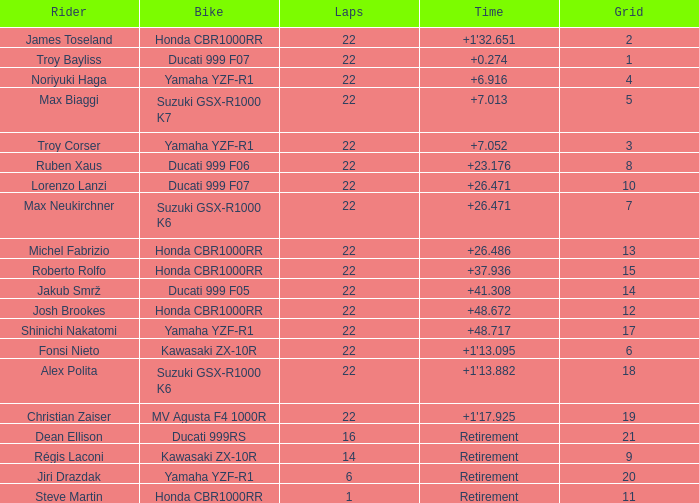Could you parse the entire table? {'header': ['Rider', 'Bike', 'Laps', 'Time', 'Grid'], 'rows': [['James Toseland', 'Honda CBR1000RR', '22', "+1'32.651", '2'], ['Troy Bayliss', 'Ducati 999 F07', '22', '+0.274', '1'], ['Noriyuki Haga', 'Yamaha YZF-R1', '22', '+6.916', '4'], ['Max Biaggi', 'Suzuki GSX-R1000 K7', '22', '+7.013', '5'], ['Troy Corser', 'Yamaha YZF-R1', '22', '+7.052', '3'], ['Ruben Xaus', 'Ducati 999 F06', '22', '+23.176', '8'], ['Lorenzo Lanzi', 'Ducati 999 F07', '22', '+26.471', '10'], ['Max Neukirchner', 'Suzuki GSX-R1000 K6', '22', '+26.471', '7'], ['Michel Fabrizio', 'Honda CBR1000RR', '22', '+26.486', '13'], ['Roberto Rolfo', 'Honda CBR1000RR', '22', '+37.936', '15'], ['Jakub Smrž', 'Ducati 999 F05', '22', '+41.308', '14'], ['Josh Brookes', 'Honda CBR1000RR', '22', '+48.672', '12'], ['Shinichi Nakatomi', 'Yamaha YZF-R1', '22', '+48.717', '17'], ['Fonsi Nieto', 'Kawasaki ZX-10R', '22', "+1'13.095", '6'], ['Alex Polita', 'Suzuki GSX-R1000 K6', '22', "+1'13.882", '18'], ['Christian Zaiser', 'MV Agusta F4 1000R', '22', "+1'17.925", '19'], ['Dean Ellison', 'Ducati 999RS', '16', 'Retirement', '21'], ['Régis Laconi', 'Kawasaki ZX-10R', '14', 'Retirement', '9'], ['Jiri Drazdak', 'Yamaha YZF-R1', '6', 'Retirement', '20'], ['Steve Martin', 'Honda CBR1000RR', '1', 'Retirement', '11']]} When the grid count is 10, what is the complete number of laps? 1.0. 